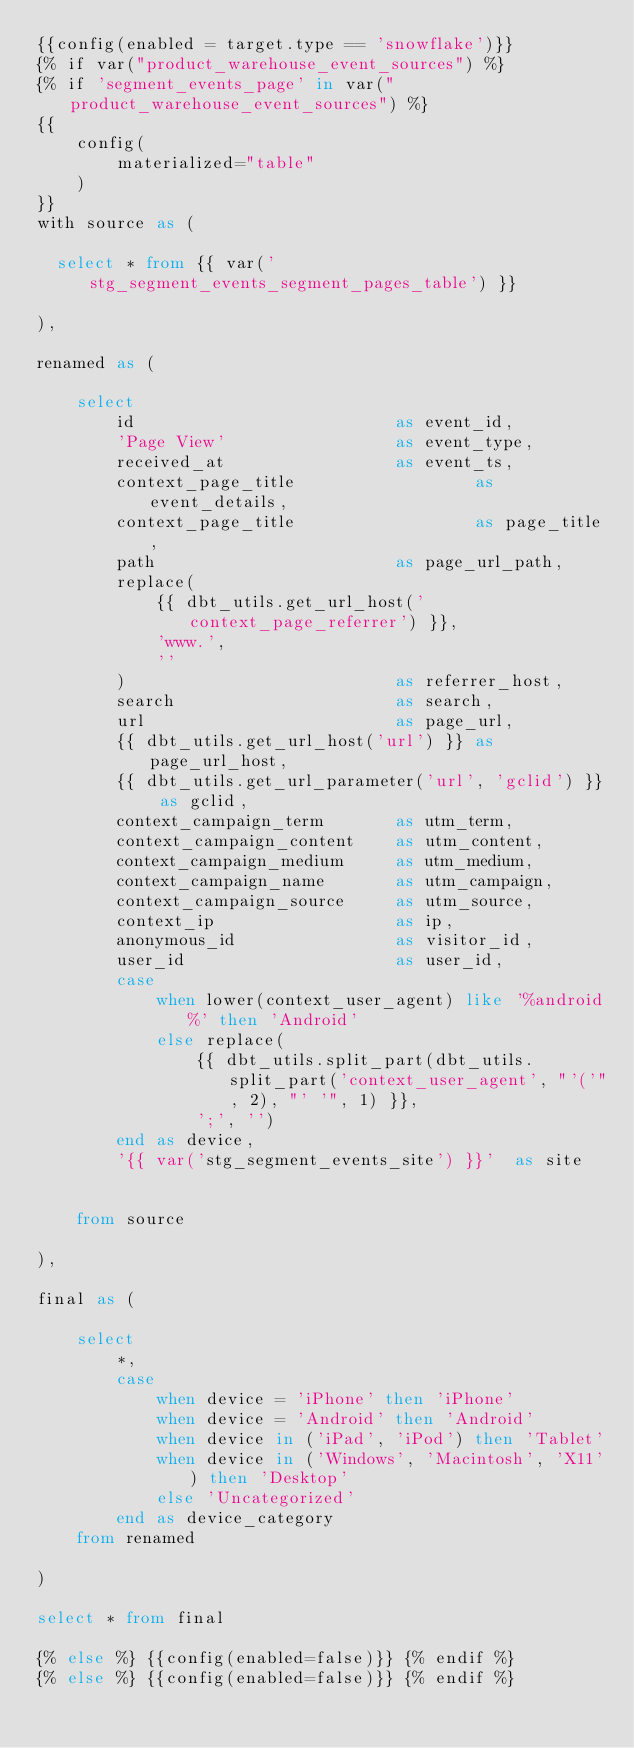Convert code to text. <code><loc_0><loc_0><loc_500><loc_500><_SQL_>{{config(enabled = target.type == 'snowflake')}}
{% if var("product_warehouse_event_sources") %}
{% if 'segment_events_page' in var("product_warehouse_event_sources") %}
{{
    config(
        materialized="table"
    )
}}
with source as (

  select * from {{ var('stg_segment_events_segment_pages_table') }}

),

renamed as (

    select
        id                          as event_id,
        'Page View'                 as event_type,
        received_at                 as event_ts,
        context_page_title                  as event_details,
        context_page_title                  as page_title,
        path                        as page_url_path,
        replace(
            {{ dbt_utils.get_url_host('context_page_referrer') }},
            'www.',
            ''
        )                           as referrer_host,
        search                      as search,
        url                         as page_url,
        {{ dbt_utils.get_url_host('url') }} as page_url_host,
        {{ dbt_utils.get_url_parameter('url', 'gclid') }} as gclid,
        context_campaign_term       as utm_term,
        context_campaign_content    as utm_content,
        context_campaign_medium     as utm_medium,
        context_campaign_name       as utm_campaign,
        context_campaign_source     as utm_source,
        context_ip                  as ip,
        anonymous_id                as visitor_id,
        user_id                     as user_id,
        case
            when lower(context_user_agent) like '%android%' then 'Android'
            else replace(
                {{ dbt_utils.split_part(dbt_utils.split_part('context_user_agent', "'('", 2), "' '", 1) }},
                ';', '')
        end as device,
        '{{ var('stg_segment_events_site') }}'  as site


    from source

),

final as (

    select
        *,
        case
            when device = 'iPhone' then 'iPhone'
            when device = 'Android' then 'Android'
            when device in ('iPad', 'iPod') then 'Tablet'
            when device in ('Windows', 'Macintosh', 'X11') then 'Desktop'
            else 'Uncategorized'
        end as device_category
    from renamed

)

select * from final

{% else %} {{config(enabled=false)}} {% endif %}
{% else %} {{config(enabled=false)}} {% endif %}
</code> 